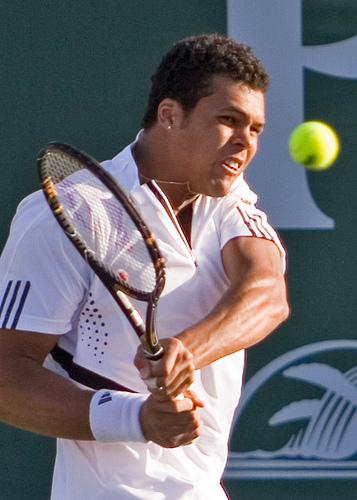What sport is this man playing?
Be succinct. Tennis. Is the ball floating right next to his face?
Give a very brief answer. No. What arm has a sweatband?
Answer briefly. Right. 